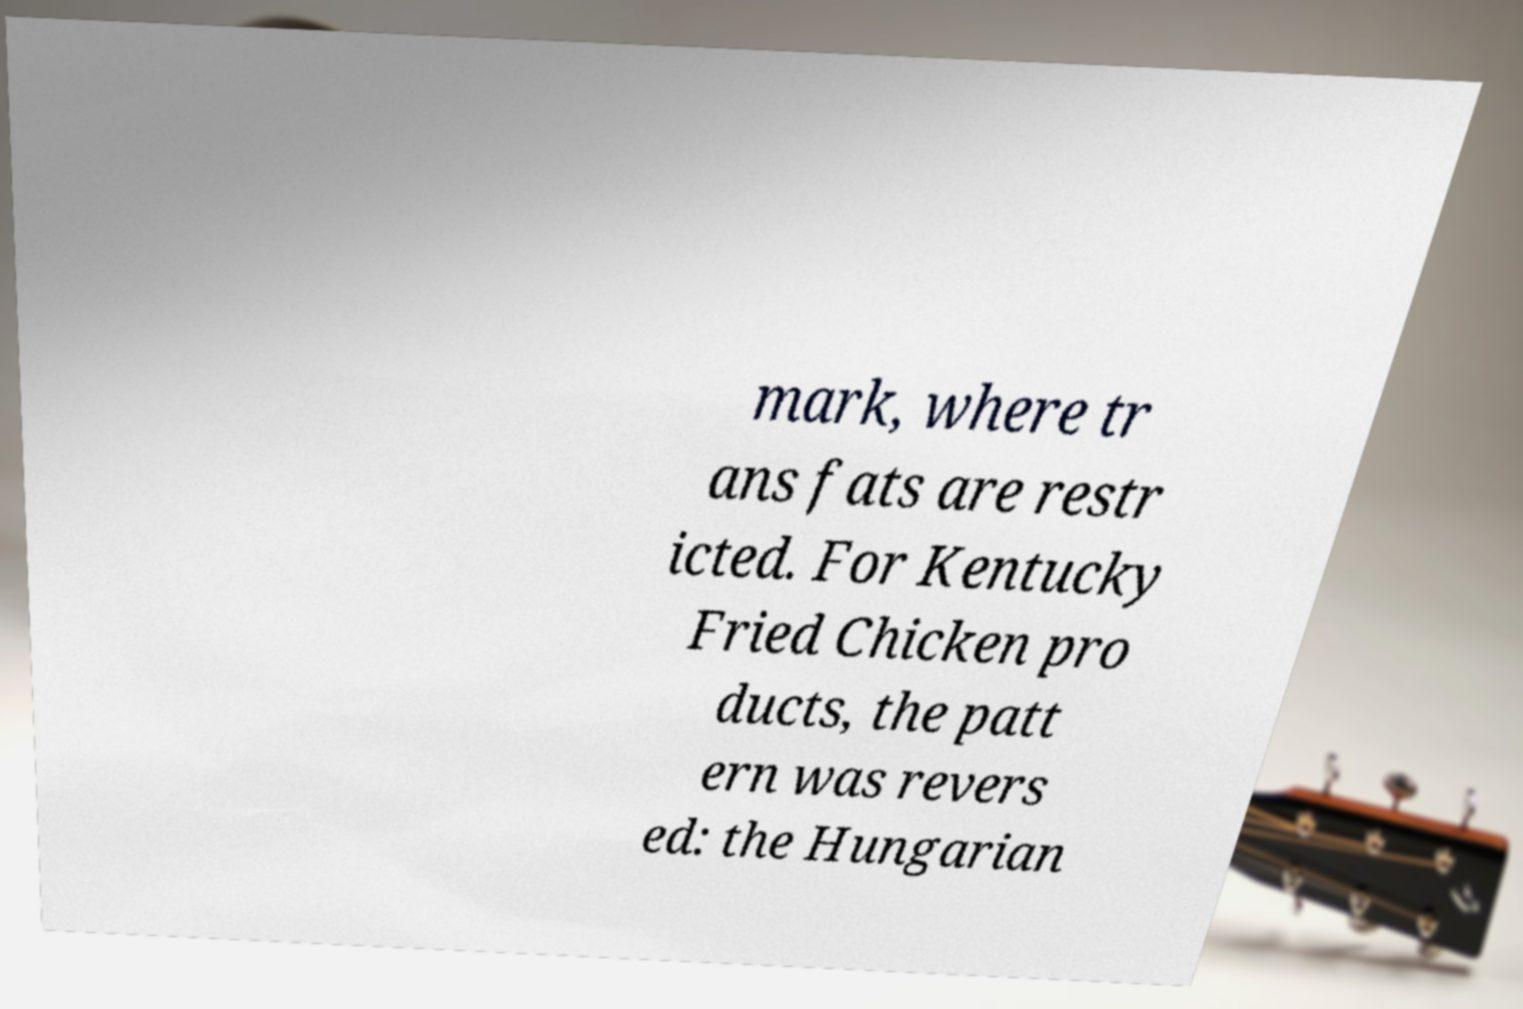I need the written content from this picture converted into text. Can you do that? mark, where tr ans fats are restr icted. For Kentucky Fried Chicken pro ducts, the patt ern was revers ed: the Hungarian 